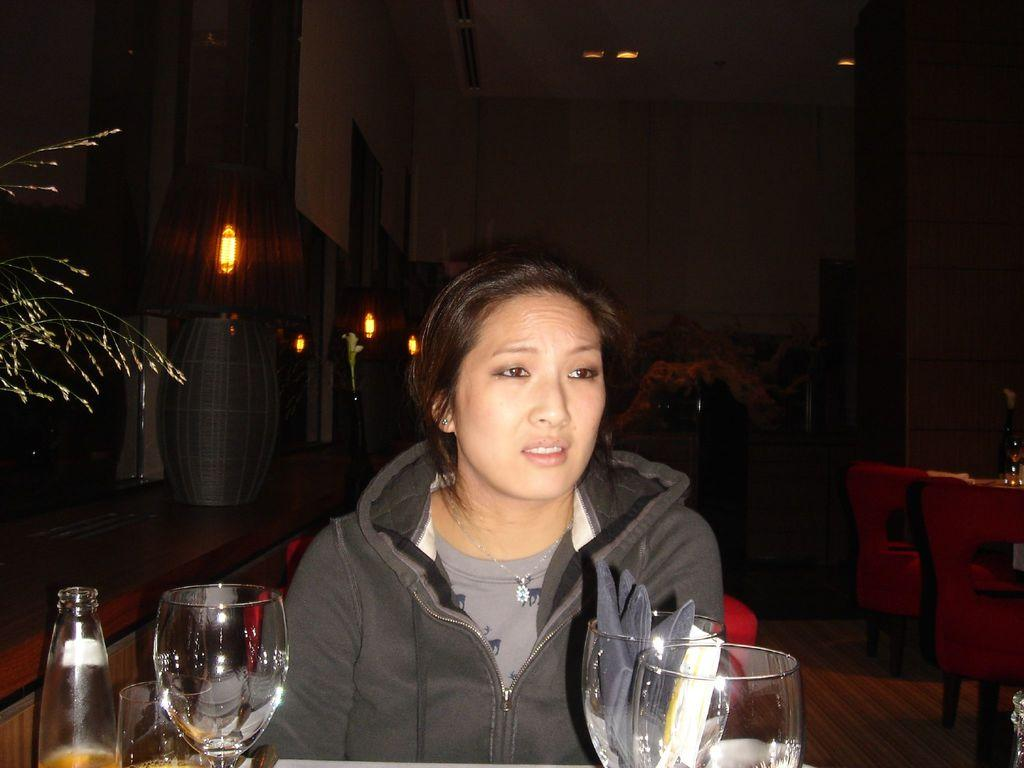What is the primary subject in the image? There is a woman in the picture. What is the woman doing in the image? The woman is sitting and staring at something. What is on the table in front of the woman? There are wine glasses, a wine bottle, and napkins on the table. What type of gun is the scarecrow holding in the image? There is no scarecrow or gun present in the image. How many worms can be seen crawling on the table in the image? There are no worms present in the image; the table contains wine glasses, a wine bottle, and napkins. 